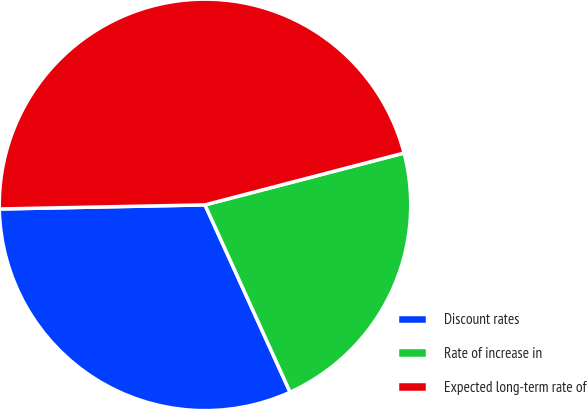<chart> <loc_0><loc_0><loc_500><loc_500><pie_chart><fcel>Discount rates<fcel>Rate of increase in<fcel>Expected long-term rate of<nl><fcel>31.47%<fcel>22.27%<fcel>46.26%<nl></chart> 